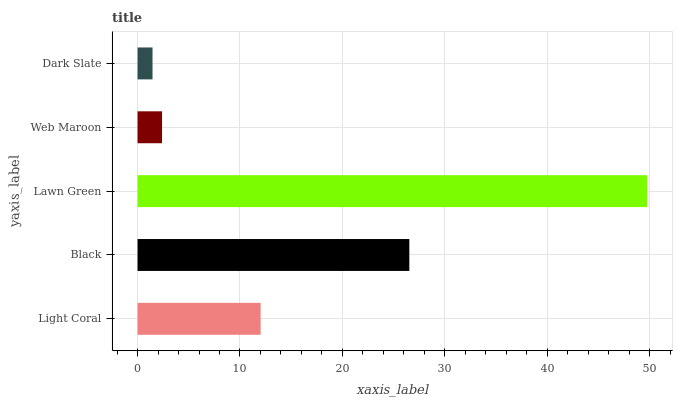Is Dark Slate the minimum?
Answer yes or no. Yes. Is Lawn Green the maximum?
Answer yes or no. Yes. Is Black the minimum?
Answer yes or no. No. Is Black the maximum?
Answer yes or no. No. Is Black greater than Light Coral?
Answer yes or no. Yes. Is Light Coral less than Black?
Answer yes or no. Yes. Is Light Coral greater than Black?
Answer yes or no. No. Is Black less than Light Coral?
Answer yes or no. No. Is Light Coral the high median?
Answer yes or no. Yes. Is Light Coral the low median?
Answer yes or no. Yes. Is Black the high median?
Answer yes or no. No. Is Black the low median?
Answer yes or no. No. 